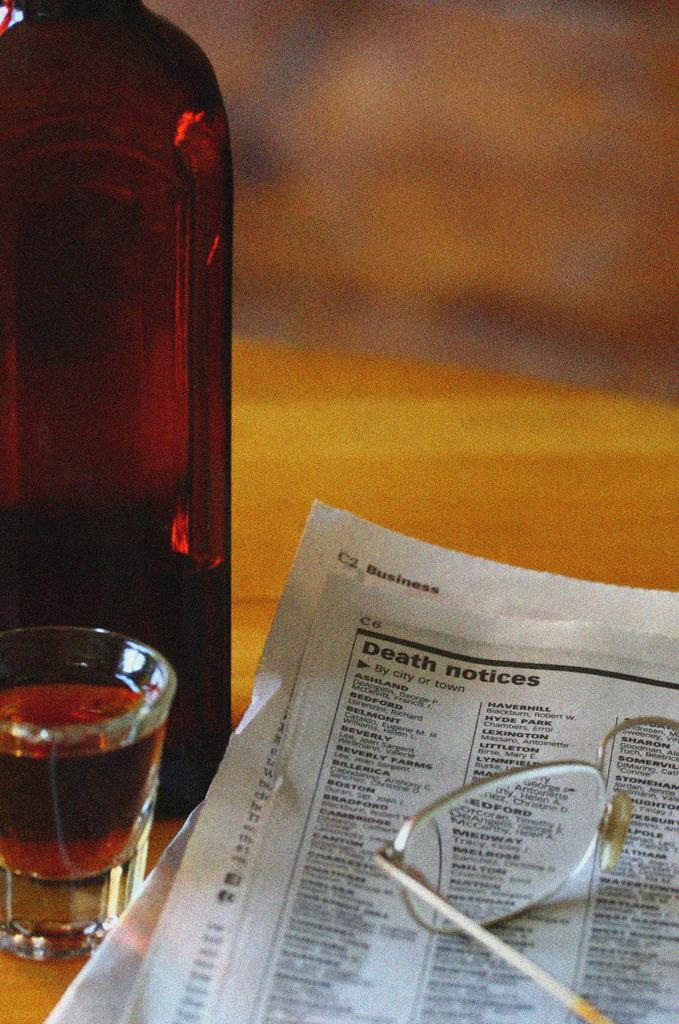What is the primary object in the image? There is a paper in the image. What other objects can be seen on the table? There are spectacles and a glass in the image. Where are all the objects located? All objects are on a table. Are there any hot items on the table in the image? There is no mention of any hot items in the image; the objects mentioned are a paper, spectacles, and a glass. 